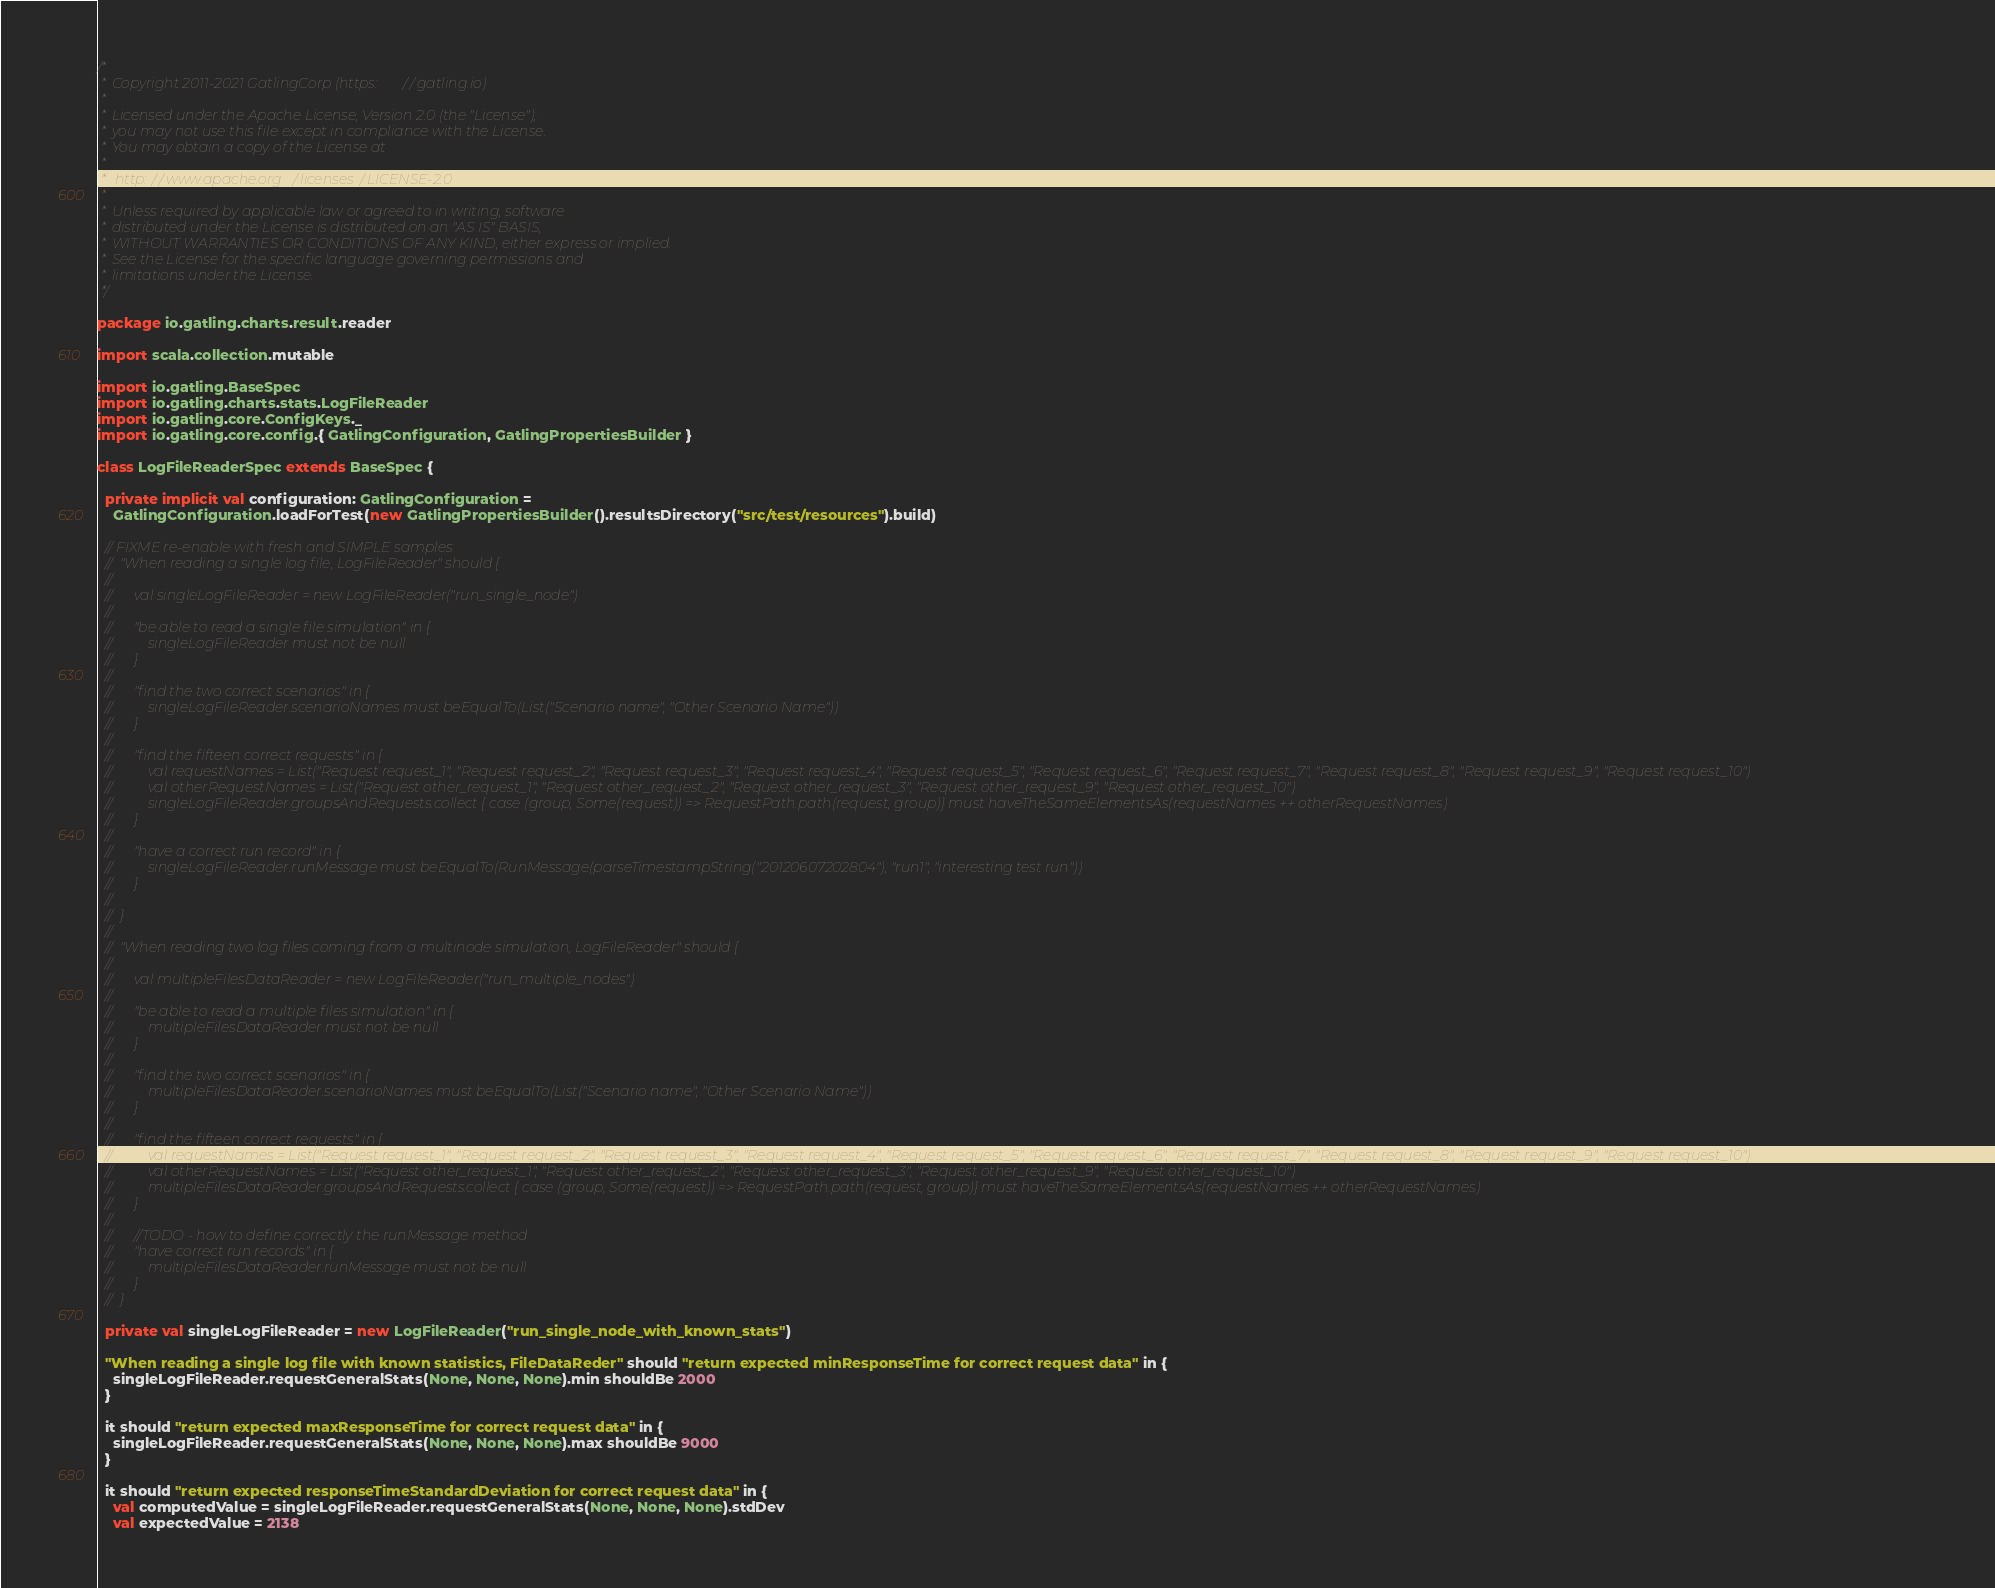<code> <loc_0><loc_0><loc_500><loc_500><_Scala_>/*
 * Copyright 2011-2021 GatlingCorp (https://gatling.io)
 *
 * Licensed under the Apache License, Version 2.0 (the "License");
 * you may not use this file except in compliance with the License.
 * You may obtain a copy of the License at
 *
 *  http://www.apache.org/licenses/LICENSE-2.0
 *
 * Unless required by applicable law or agreed to in writing, software
 * distributed under the License is distributed on an "AS IS" BASIS,
 * WITHOUT WARRANTIES OR CONDITIONS OF ANY KIND, either express or implied.
 * See the License for the specific language governing permissions and
 * limitations under the License.
 */

package io.gatling.charts.result.reader

import scala.collection.mutable

import io.gatling.BaseSpec
import io.gatling.charts.stats.LogFileReader
import io.gatling.core.ConfigKeys._
import io.gatling.core.config.{ GatlingConfiguration, GatlingPropertiesBuilder }

class LogFileReaderSpec extends BaseSpec {

  private implicit val configuration: GatlingConfiguration =
    GatlingConfiguration.loadForTest(new GatlingPropertiesBuilder().resultsDirectory("src/test/resources").build)

  // FIXME re-enable with fresh and SIMPLE samples
  //	"When reading a single log file, LogFileReader" should {
  //
  //		val singleLogFileReader = new LogFileReader("run_single_node")
  //
  //		"be able to read a single file simulation" in {
  //			singleLogFileReader must not be null
  //		}
  //
  //		"find the two correct scenarios" in {
  //			singleLogFileReader.scenarioNames must beEqualTo(List("Scenario name", "Other Scenario Name"))
  //		}
  //
  //		"find the fifteen correct requests" in {
  //			val requestNames = List("Request request_1", "Request request_2", "Request request_3", "Request request_4", "Request request_5", "Request request_6", "Request request_7", "Request request_8", "Request request_9", "Request request_10")
  //			val otherRequestNames = List("Request other_request_1", "Request other_request_2", "Request other_request_3", "Request other_request_9", "Request other_request_10")
  //			singleLogFileReader.groupsAndRequests.collect { case (group, Some(request)) => RequestPath.path(request, group)} must haveTheSameElementsAs(requestNames ++ otherRequestNames)
  //		}
  //
  //		"have a correct run record" in {
  //			singleLogFileReader.runMessage must beEqualTo(RunMessage(parseTimestampString("20120607202804"), "run1", "interesting test run"))
  //		}
  //
  //	}
  //
  //	"When reading two log files coming from a multinode simulation, LogFileReader" should {
  //
  //		val multipleFilesDataReader = new LogFileReader("run_multiple_nodes")
  //
  //		"be able to read a multiple files simulation" in {
  //			multipleFilesDataReader must not be null
  //		}
  //
  //		"find the two correct scenarios" in {
  //			multipleFilesDataReader.scenarioNames must beEqualTo(List("Scenario name", "Other Scenario Name"))
  //		}
  //
  //		"find the fifteen correct requests" in {
  //			val requestNames = List("Request request_1", "Request request_2", "Request request_3", "Request request_4", "Request request_5", "Request request_6", "Request request_7", "Request request_8", "Request request_9", "Request request_10")
  //			val otherRequestNames = List("Request other_request_1", "Request other_request_2", "Request other_request_3", "Request other_request_9", "Request other_request_10")
  //			multipleFilesDataReader.groupsAndRequests.collect { case (group, Some(request)) => RequestPath.path(request, group)} must haveTheSameElementsAs(requestNames ++ otherRequestNames)
  //		}
  //
  //		//TODO - how to define correctly the runMessage method
  //		"have correct run records" in {
  //			multipleFilesDataReader.runMessage must not be null
  //		}
  //	}

  private val singleLogFileReader = new LogFileReader("run_single_node_with_known_stats")

  "When reading a single log file with known statistics, FileDataReder" should "return expected minResponseTime for correct request data" in {
    singleLogFileReader.requestGeneralStats(None, None, None).min shouldBe 2000
  }

  it should "return expected maxResponseTime for correct request data" in {
    singleLogFileReader.requestGeneralStats(None, None, None).max shouldBe 9000
  }

  it should "return expected responseTimeStandardDeviation for correct request data" in {
    val computedValue = singleLogFileReader.requestGeneralStats(None, None, None).stdDev
    val expectedValue = 2138</code> 